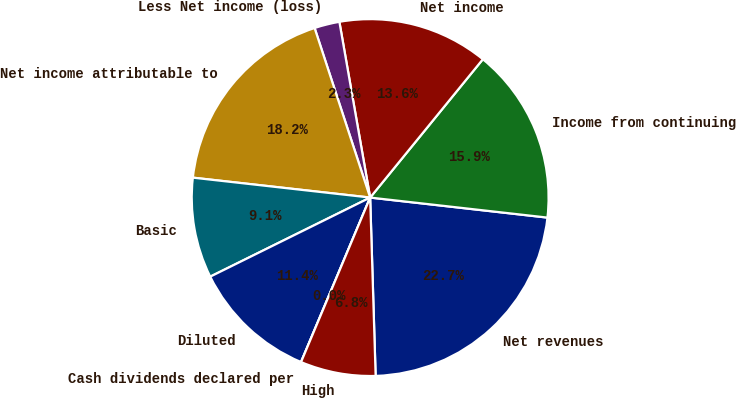Convert chart. <chart><loc_0><loc_0><loc_500><loc_500><pie_chart><fcel>Net revenues<fcel>Income from continuing<fcel>Net income<fcel>Less Net income (loss)<fcel>Net income attributable to<fcel>Basic<fcel>Diluted<fcel>Cash dividends declared per<fcel>High<nl><fcel>22.72%<fcel>15.91%<fcel>13.64%<fcel>2.28%<fcel>18.18%<fcel>9.09%<fcel>11.36%<fcel>0.0%<fcel>6.82%<nl></chart> 